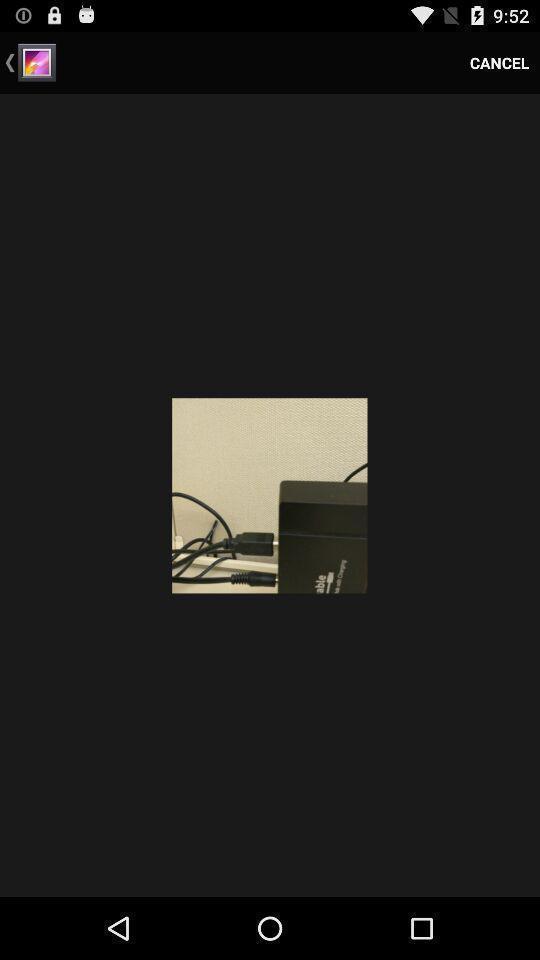Describe this image in words. Page showing an image on a device. 